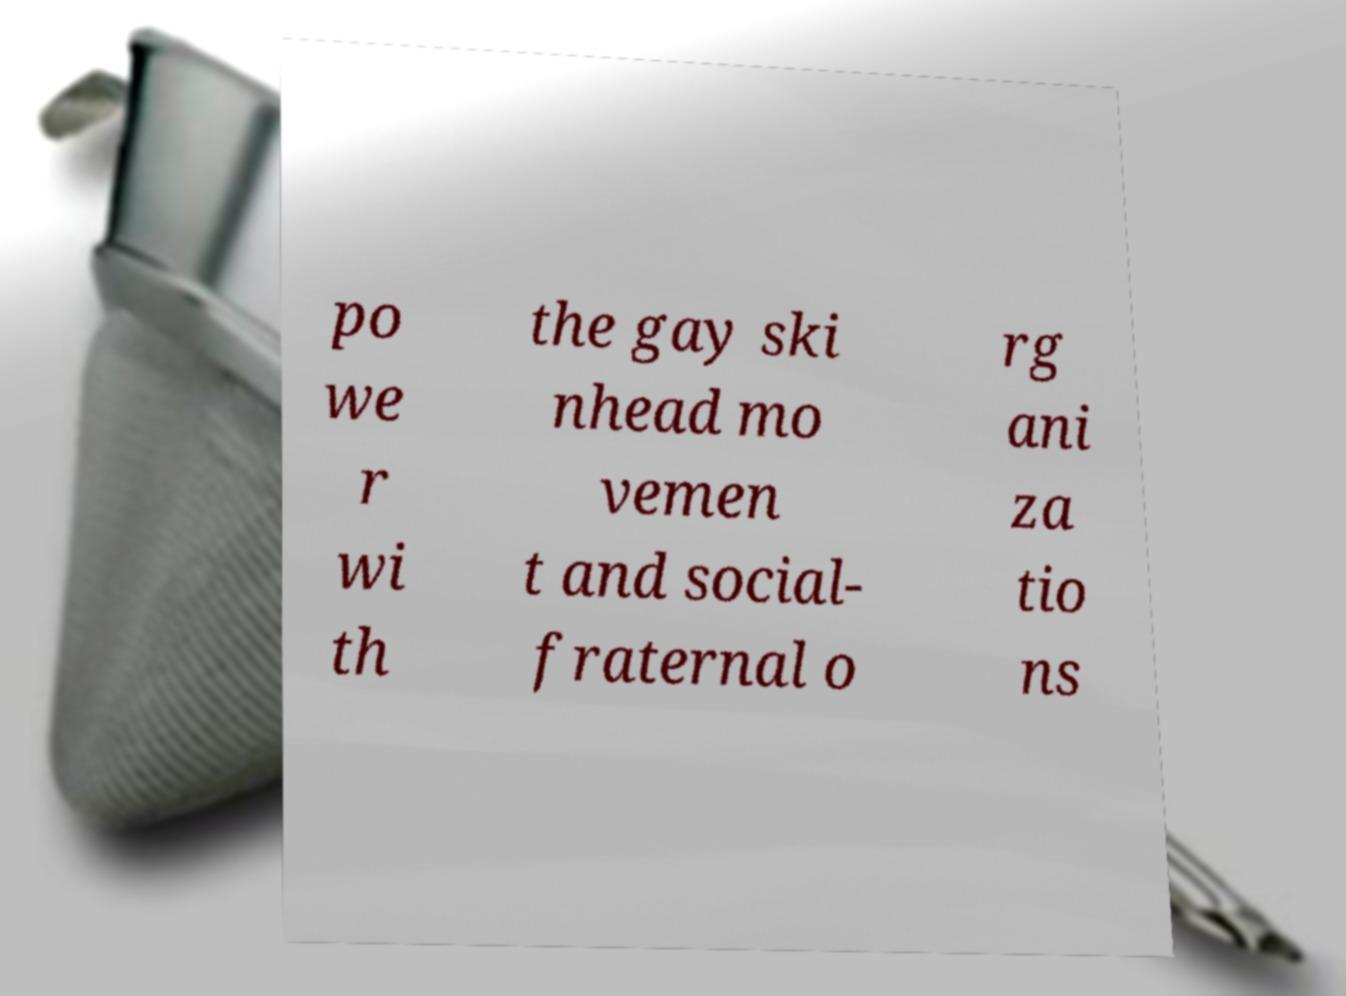For documentation purposes, I need the text within this image transcribed. Could you provide that? po we r wi th the gay ski nhead mo vemen t and social- fraternal o rg ani za tio ns 